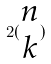<formula> <loc_0><loc_0><loc_500><loc_500>2 ( \begin{matrix} n \\ k \end{matrix} )</formula> 